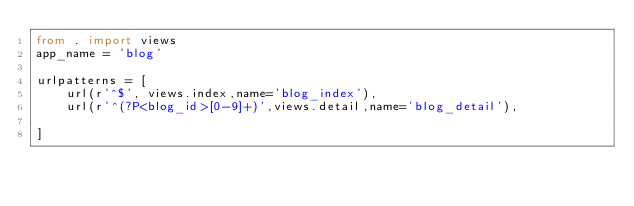Convert code to text. <code><loc_0><loc_0><loc_500><loc_500><_Python_>from . import views
app_name = 'blog'

urlpatterns = [
    url(r'^$', views.index,name='blog_index'),
    url(r'^(?P<blog_id>[0-9]+)',views.detail,name='blog_detail'),

]
</code> 